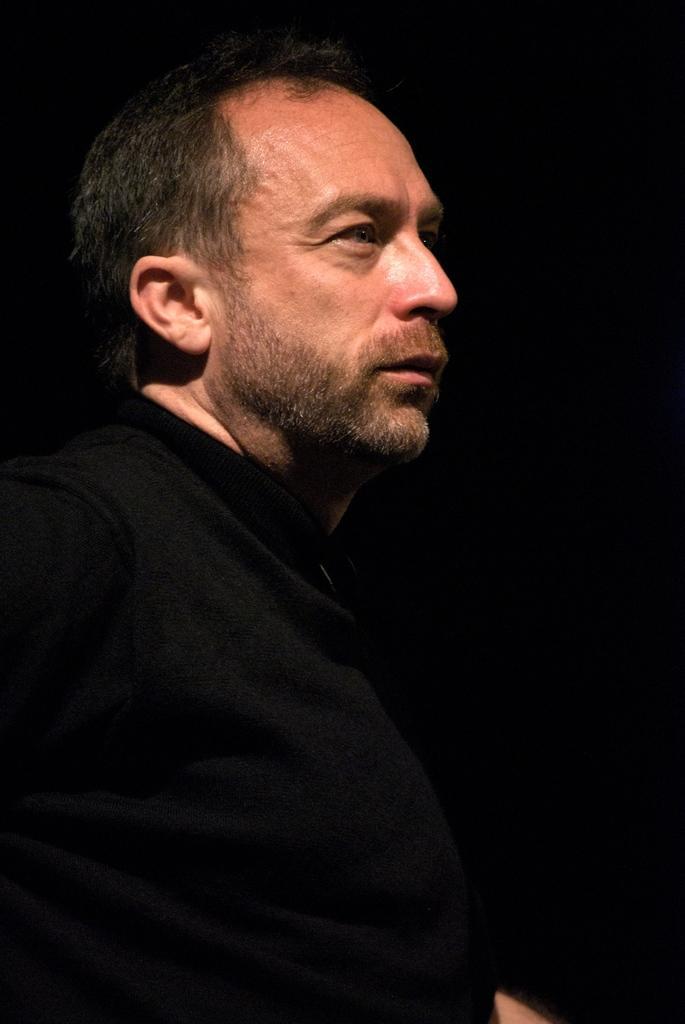Describe this image in one or two sentences. In this picture we can see a man in the black t shirt and behind the man there is a dark background. 